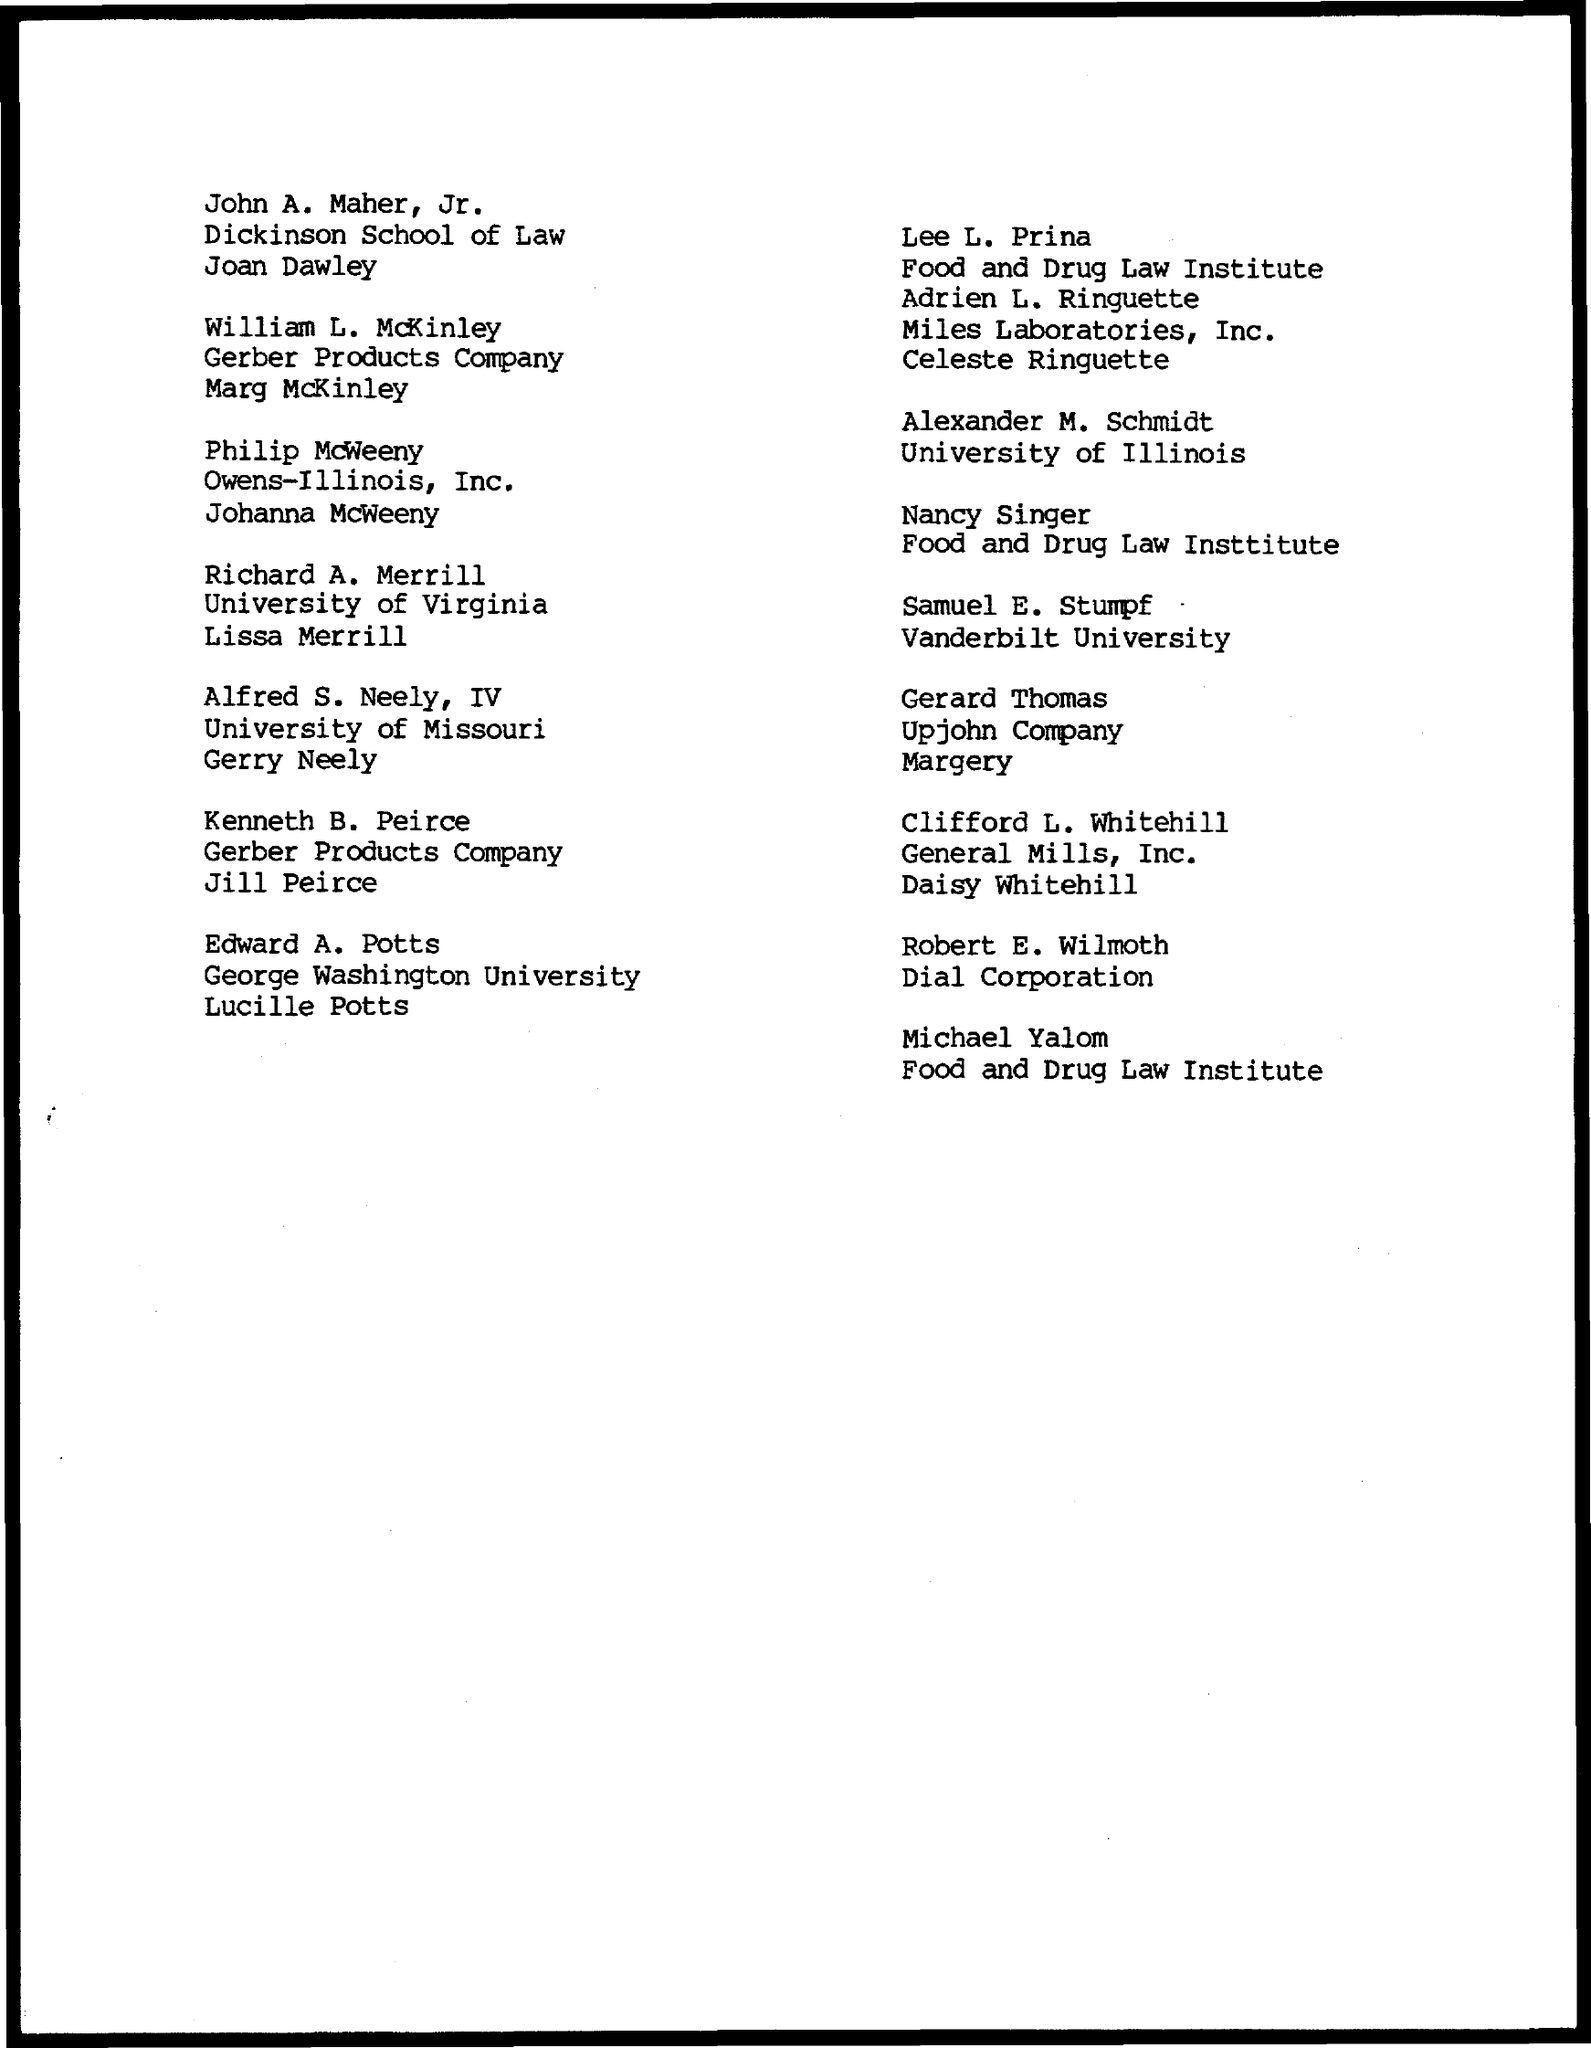List a handful of essential elements in this visual. Gerard Thomas is a member of the Upjohn Company. Samuel E. Stumpf is a member of Vanderbilt University. Robert E. Wilmoth is a member of the Dial Corporation. Alexander M. Schmidt is a member of the University of Illinois. 